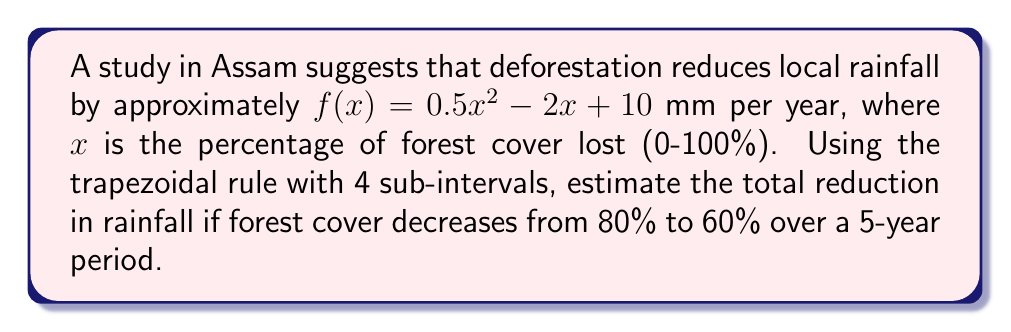Show me your answer to this math problem. To solve this problem, we'll use the trapezoidal rule for numerical integration:

1) The interval is from 80% to 60% forest cover, so $a = 20$ and $b = 40$ (since we're measuring loss).

2) Number of sub-intervals, $n = 4$

3) Width of each sub-interval, $h = \frac{b-a}{n} = \frac{40-20}{4} = 5$

4) The trapezoidal rule formula is:

   $$\int_a^b f(x)dx \approx \frac{h}{2}[f(x_0) + 2f(x_1) + 2f(x_2) + 2f(x_3) + f(x_4)]$$

5) Calculate function values:
   $f(20) = 0.5(20)^2 - 2(20) + 10 = 170$
   $f(25) = 0.5(25)^2 - 2(25) + 10 = 247.5$
   $f(30) = 0.5(30)^2 - 2(30) + 10 = 340$
   $f(35) = 0.5(35)^2 - 2(35) + 10 = 447.5$
   $f(40) = 0.5(40)^2 - 2(40) + 10 = 570$

6) Apply the trapezoidal rule:
   $$\int_{20}^{40} f(x)dx \approx \frac{5}{2}[170 + 2(247.5) + 2(340) + 2(447.5) + 570]$$
   $$= \frac{5}{2}[170 + 495 + 680 + 895 + 570] = \frac{5}{2}(2810) = 7025$$

7) This result is for one year. For 5 years, multiply by 5:
   $7025 * 5 = 35125$ mm

Therefore, the estimated total reduction in rainfall over 5 years is 35,125 mm or approximately 35.13 meters.
Answer: 35.13 meters 